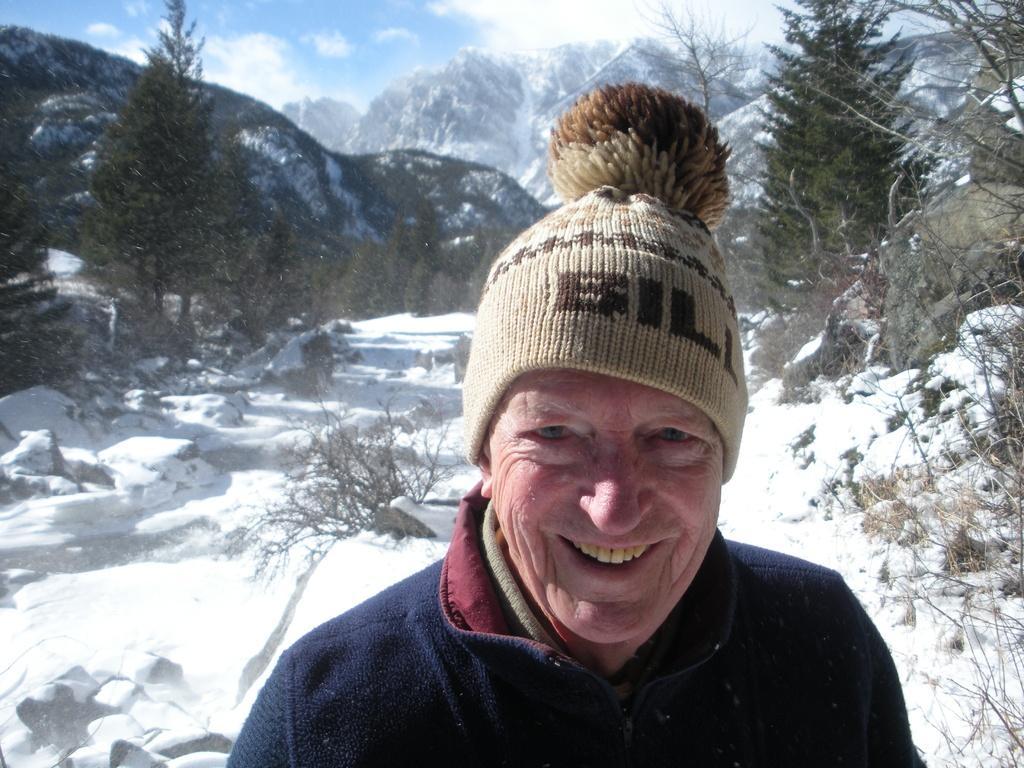In one or two sentences, can you explain what this image depicts? In this picture we can see one person is standing on the snow and taking picture. 